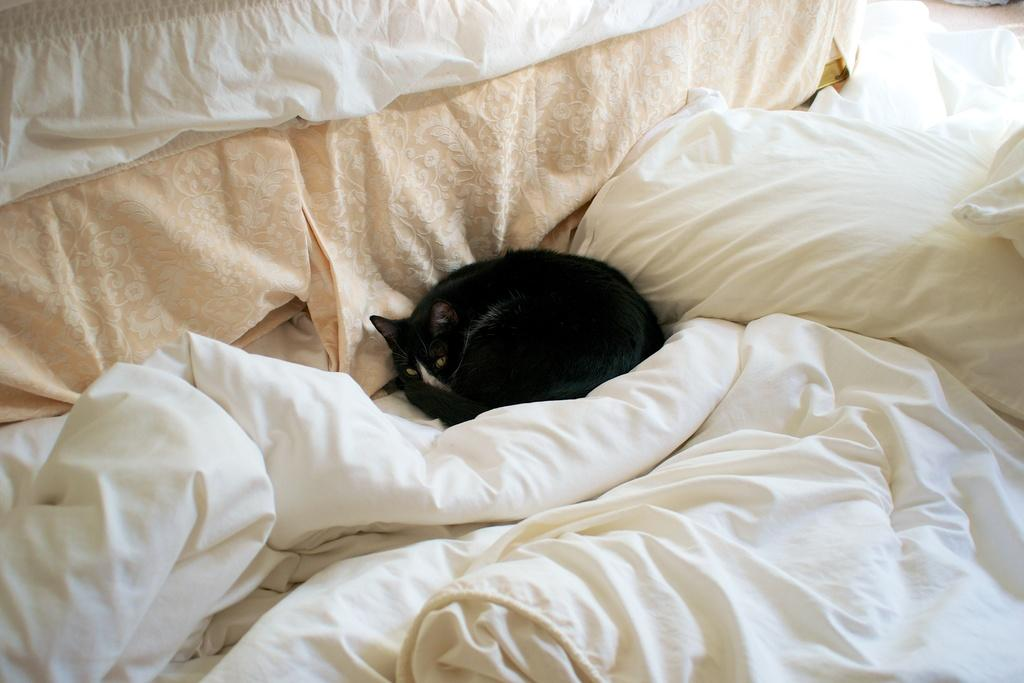What piece of furniture is present in the image? There is a bed in the image. What is placed on the bed? There is a pillow and blankets on the bed. What type of animal can be seen in the image? There is a cat in the middle of the image. What can be seen in the background of the image? There are many clothes in the background of the image. How does the cat's stomach feel in the image? The image does not provide information about the cat's stomach, so it cannot be determined from the image. 